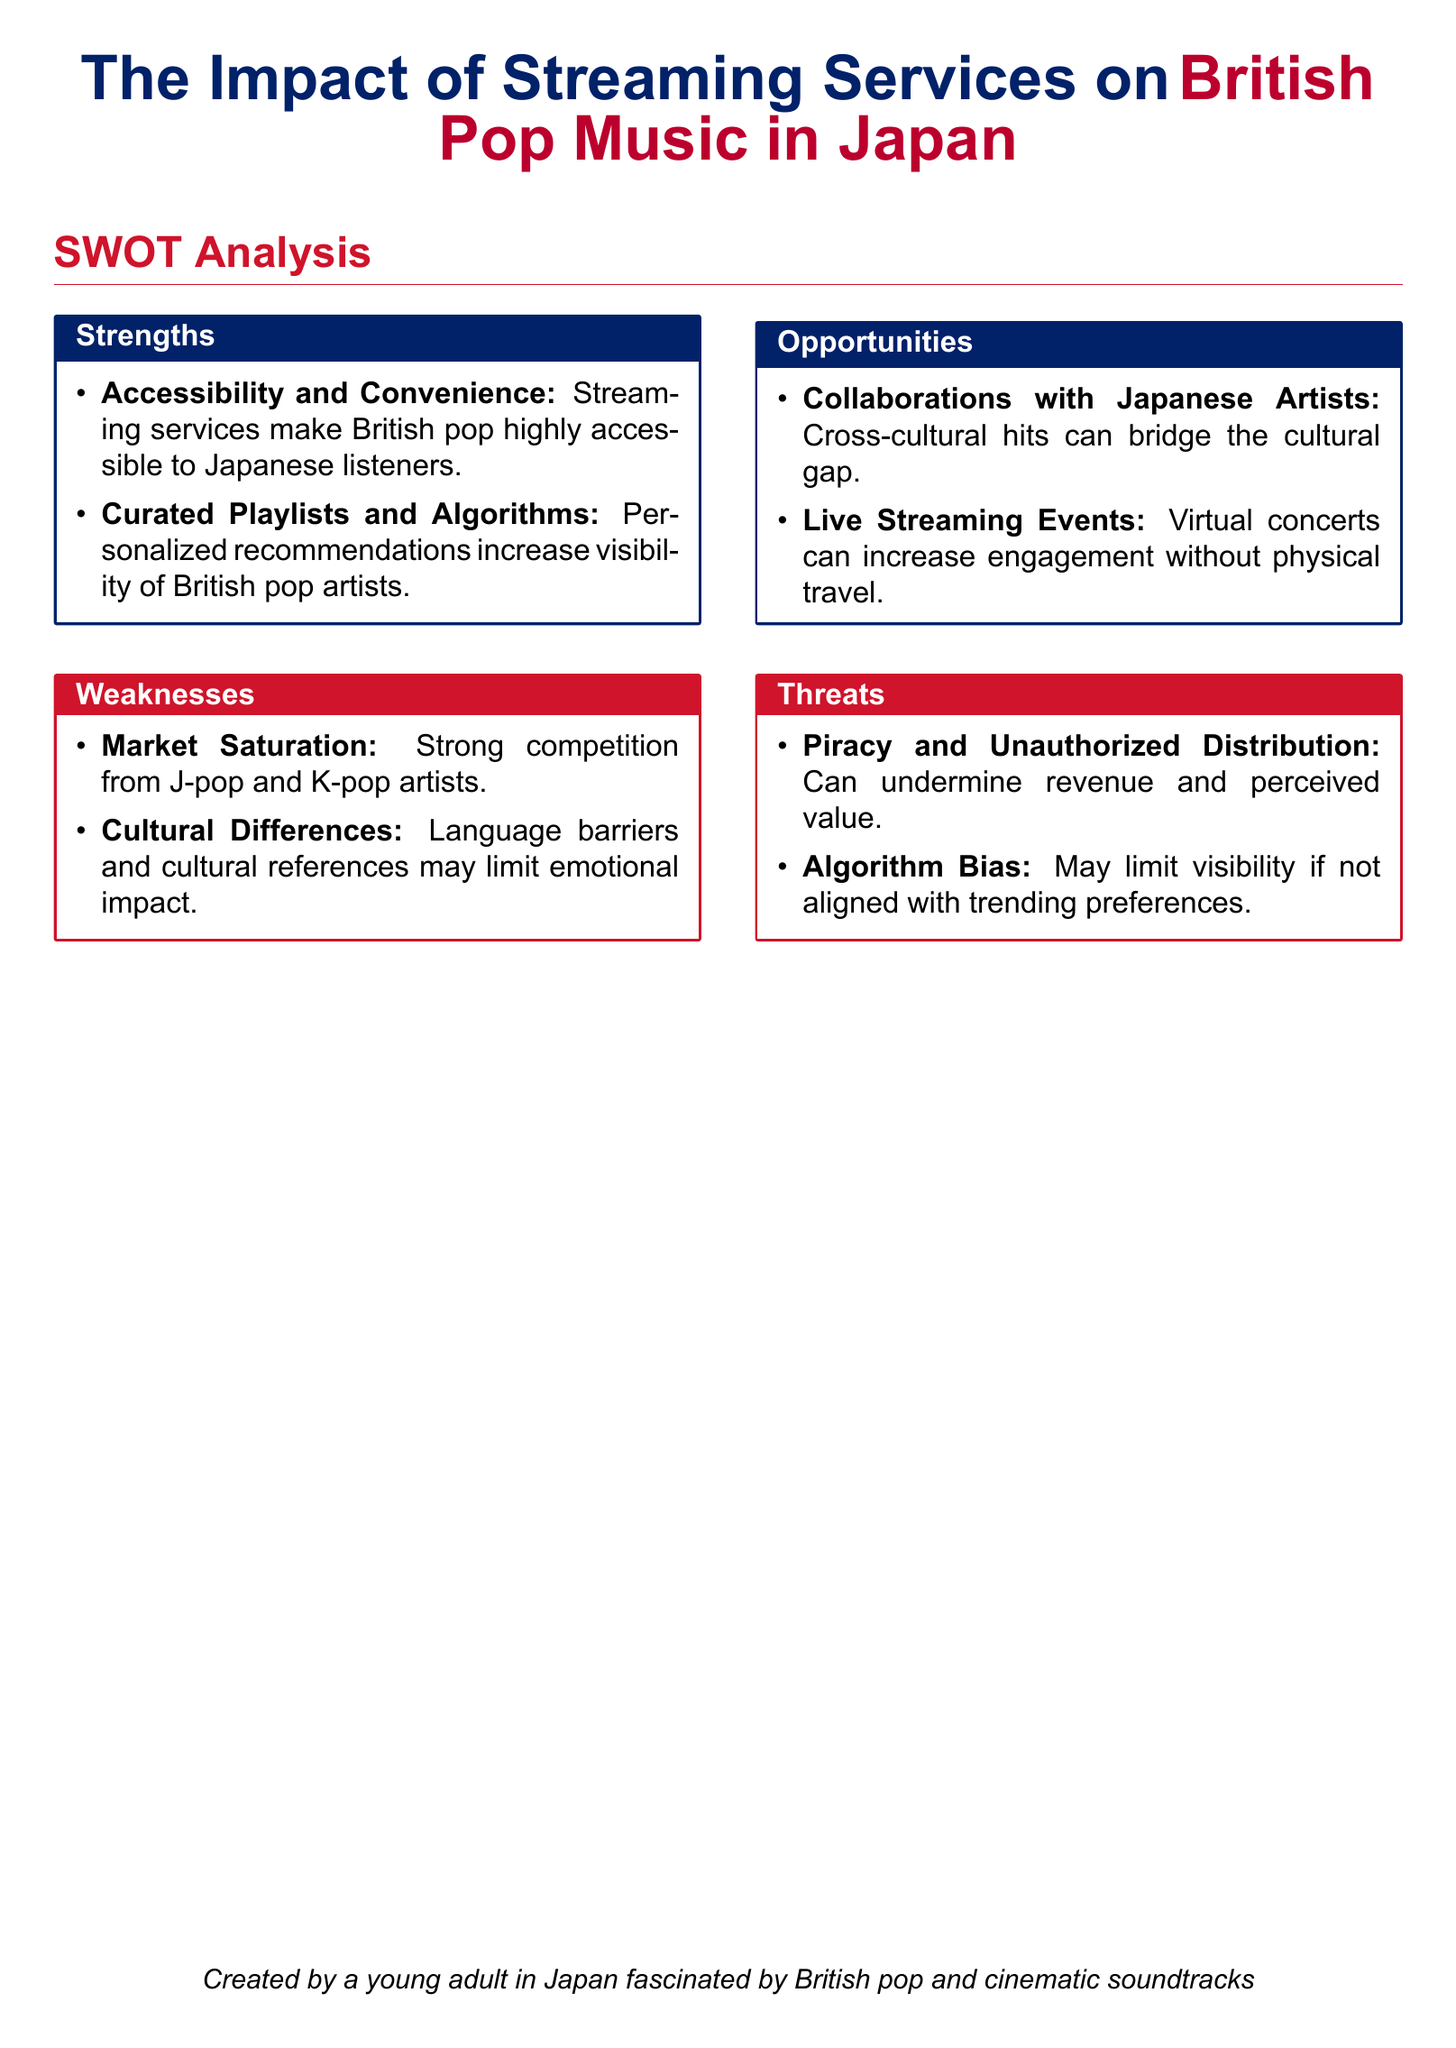What are the strengths of streaming services for British pop music in Japan? The strengths include accessibility and convenience, as well as curated playlists and algorithms that increase visibility.
Answer: Accessibility and Convenience; Curated Playlists and Algorithms What is one of the weaknesses identified in the document? The weaknesses include market saturation due to strong competition and cultural differences that might limit emotional impact.
Answer: Market Saturation What opportunities exist for British pop music in Japan according to the SWOT analysis? Opportunities listed are collaborations with Japanese artists and live streaming events.
Answer: Collaborations with Japanese Artists; Live Streaming Events What is a potential threat to British pop music from streaming services? One identified threat is piracy and unauthorized distribution, which can undermine revenue and perceived value.
Answer: Piracy and Unauthorized Distribution How many main categories are analyzed in this SWOT analysis? The document contains four main categories: Strengths, Weaknesses, Opportunities, and Threats.
Answer: Four What color is used for the 'Strengths' section title? The 'Strengths' section title is colored in British blue.
Answer: British Blue What is the primary purpose of curated playlists and algorithms according to the document? Curated playlists and algorithms increase the visibility of British pop artists.
Answer: Increase visibility of British pop artists What factor may limit the emotional impact of British pop music on Japanese audiences? Cultural differences, including language barriers and cultural references, may limit emotional impact.
Answer: Cultural differences 